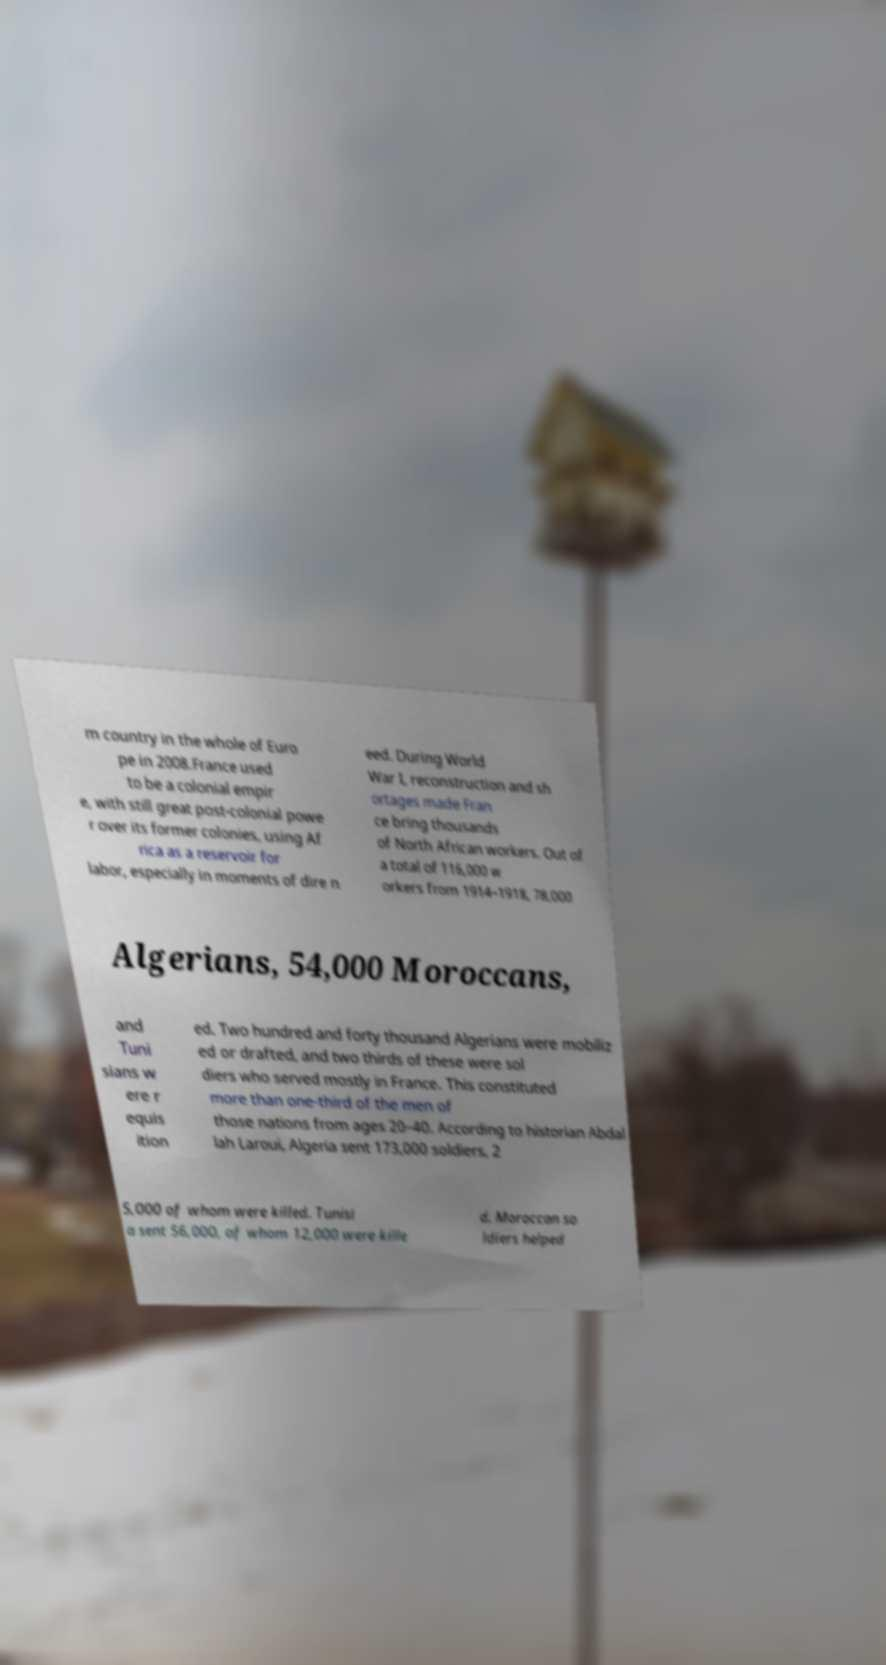Can you read and provide the text displayed in the image?This photo seems to have some interesting text. Can you extract and type it out for me? m country in the whole of Euro pe in 2008.France used to be a colonial empir e, with still great post-colonial powe r over its former colonies, using Af rica as a reservoir for labor, especially in moments of dire n eed. During World War I, reconstruction and sh ortages made Fran ce bring thousands of North African workers. Out of a total of 116,000 w orkers from 1914–1918, 78,000 Algerians, 54,000 Moroccans, and Tuni sians w ere r equis ition ed. Two hundred and forty thousand Algerians were mobiliz ed or drafted, and two thirds of these were sol diers who served mostly in France. This constituted more than one-third of the men of those nations from ages 20–40. According to historian Abdal lah Laroui, Algeria sent 173,000 soldiers, 2 5,000 of whom were killed. Tunisi a sent 56,000, of whom 12,000 were kille d. Moroccan so ldiers helped 